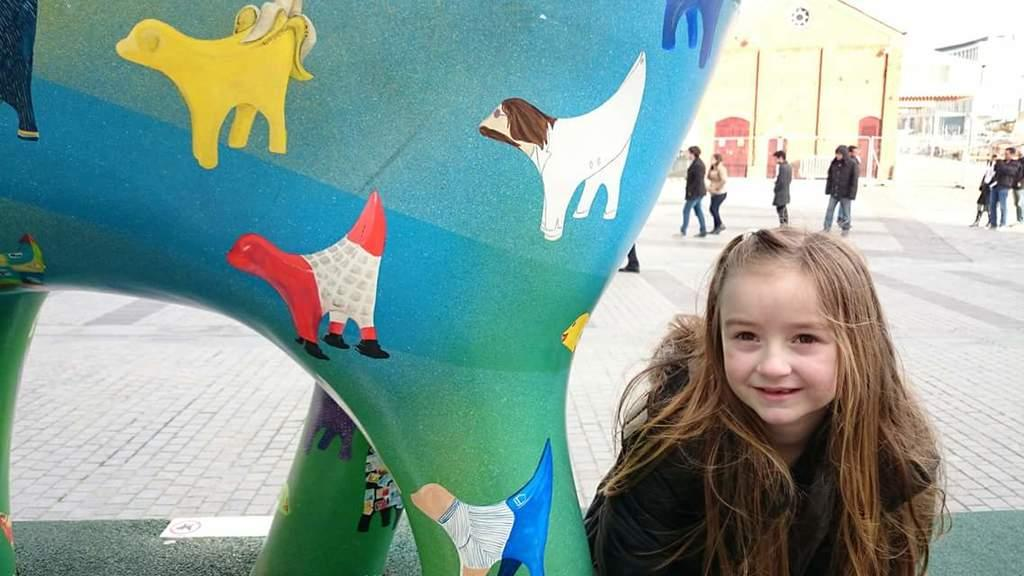Who is the main subject in the image? There is a girl in the image. What is the girl doing in the image? The girl is smiling. What object is visible in the image besides the girl? There is a balloon in the image. What can be seen in the background of the image? There are persons standing and walking in the background, as well as buildings. What type of egg is being used as a prop in the image? There is no egg present in the image. Can you tell me how many pets are visible in the image? There are no pets visible in the image. 